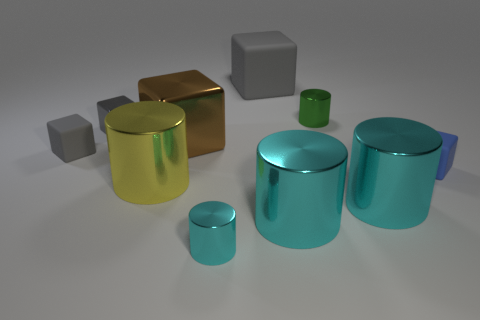Can you describe the colors and materials of the objects in the image? The image showcases several objects with reflective surfaces. There is a golden yellow cylinder, a silver cube, and multiple teal-colored cylinders of varying sizes. Their polished surfaces suggest they could be made of materials like metal or plastic, which give off specular highlights conveying a sense of smoothness and shininess. 